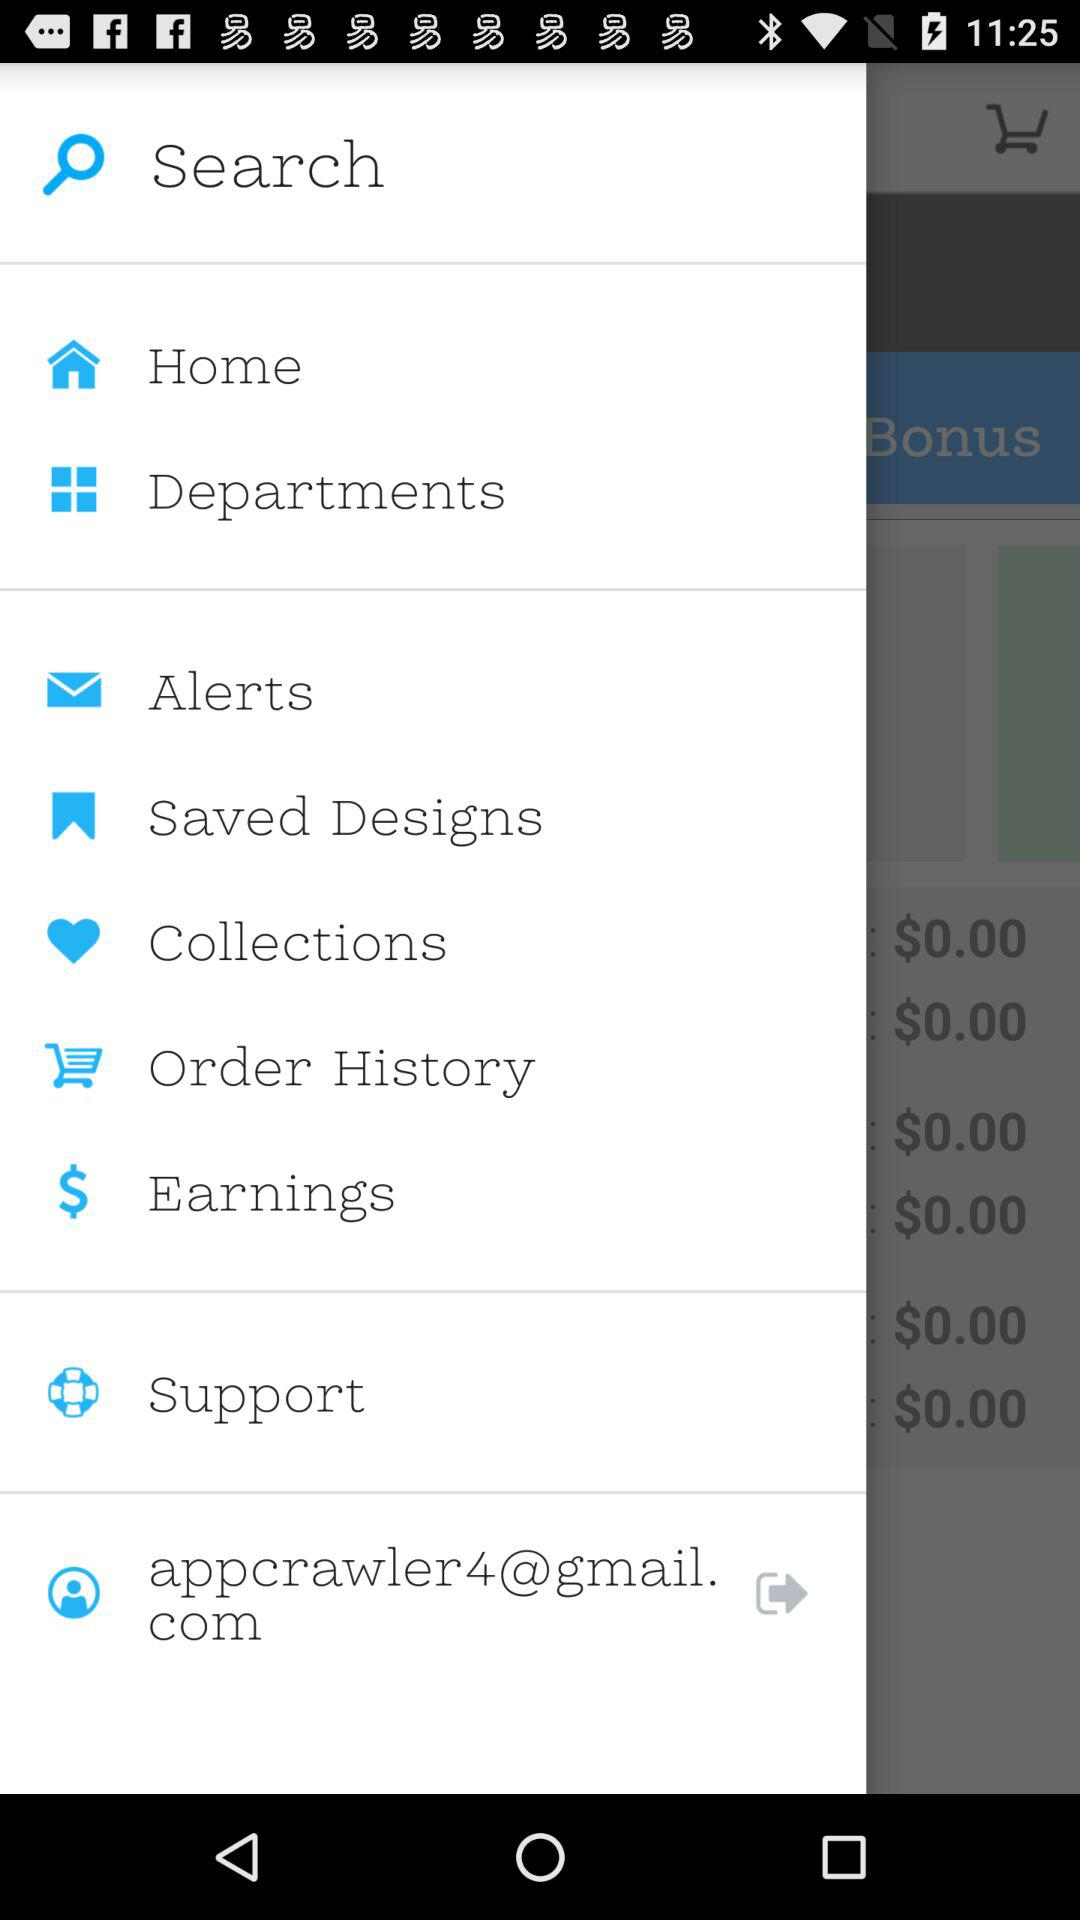What is the e-mail address? The e-mail address is appcrawler4@gmail.com. 